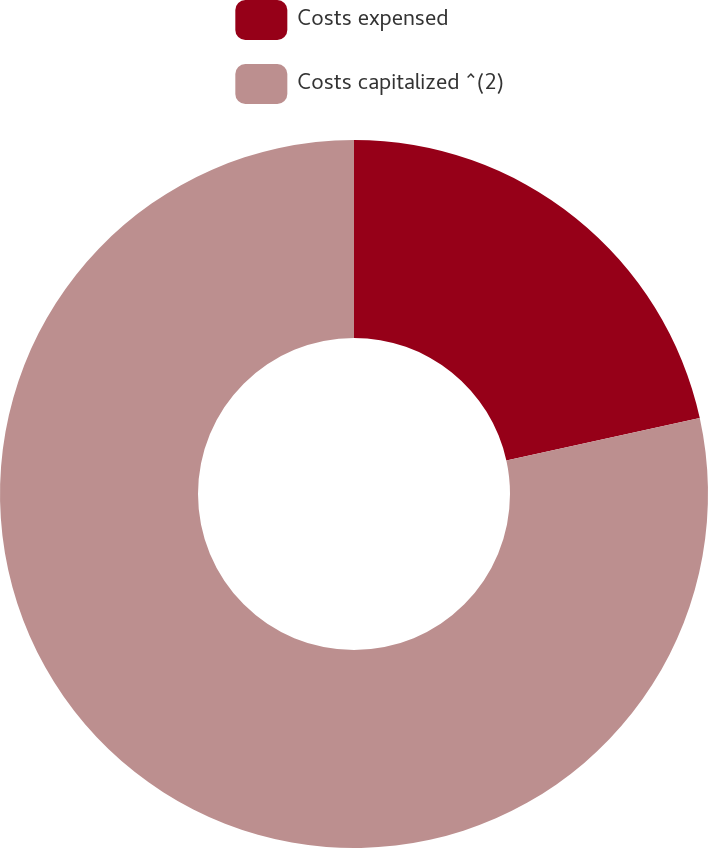Convert chart. <chart><loc_0><loc_0><loc_500><loc_500><pie_chart><fcel>Costs expensed<fcel>Costs capitalized ^(2)<nl><fcel>21.56%<fcel>78.44%<nl></chart> 